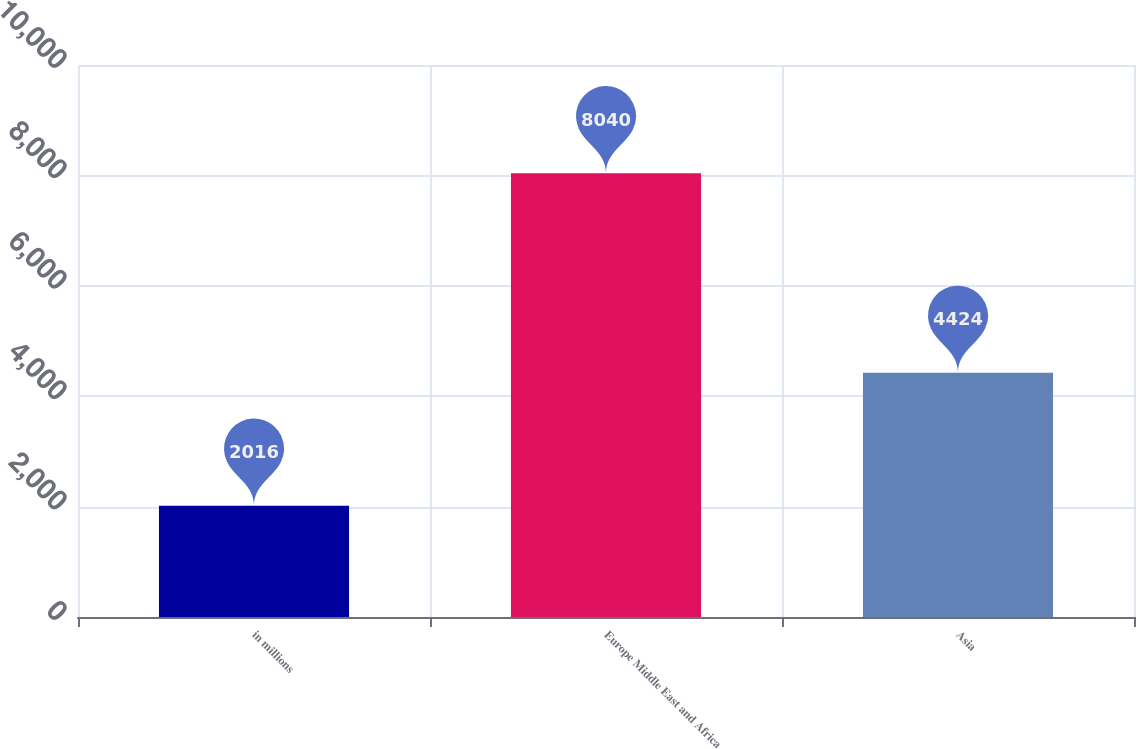Convert chart to OTSL. <chart><loc_0><loc_0><loc_500><loc_500><bar_chart><fcel>in millions<fcel>Europe Middle East and Africa<fcel>Asia<nl><fcel>2016<fcel>8040<fcel>4424<nl></chart> 